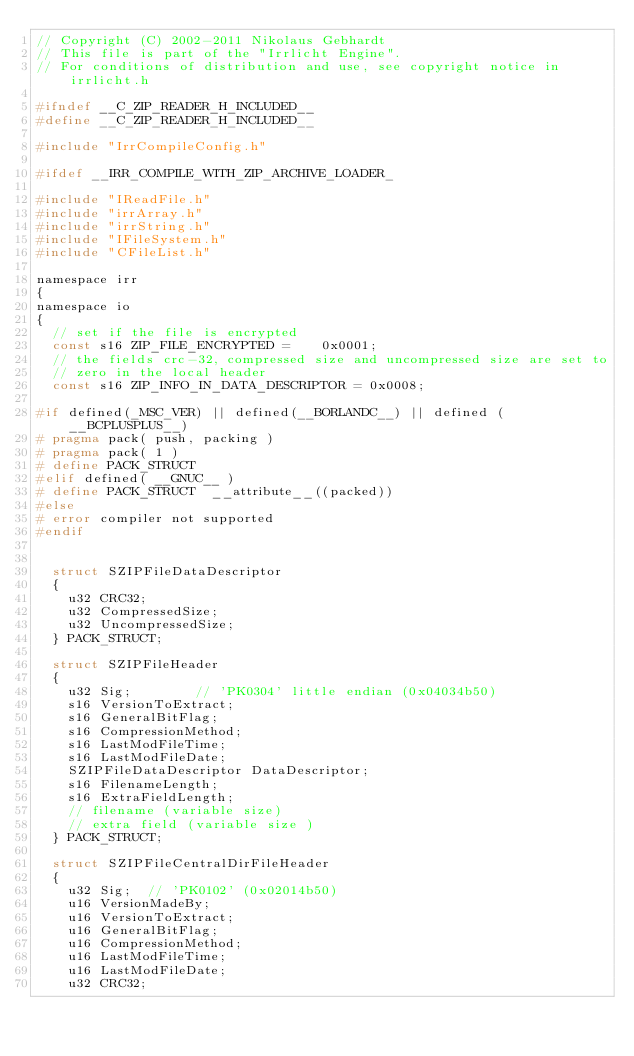<code> <loc_0><loc_0><loc_500><loc_500><_C_>// Copyright (C) 2002-2011 Nikolaus Gebhardt
// This file is part of the "Irrlicht Engine".
// For conditions of distribution and use, see copyright notice in irrlicht.h

#ifndef __C_ZIP_READER_H_INCLUDED__
#define __C_ZIP_READER_H_INCLUDED__

#include "IrrCompileConfig.h"

#ifdef __IRR_COMPILE_WITH_ZIP_ARCHIVE_LOADER_

#include "IReadFile.h"
#include "irrArray.h"
#include "irrString.h"
#include "IFileSystem.h"
#include "CFileList.h"

namespace irr
{
namespace io
{
	// set if the file is encrypted
	const s16 ZIP_FILE_ENCRYPTED =		0x0001;
	// the fields crc-32, compressed size and uncompressed size are set to
	// zero in the local header
	const s16 ZIP_INFO_IN_DATA_DESCRIPTOR =	0x0008;

#if defined(_MSC_VER) || defined(__BORLANDC__) || defined (__BCPLUSPLUS__)
#	pragma pack( push, packing )
#	pragma pack( 1 )
#	define PACK_STRUCT
#elif defined( __GNUC__ )
#	define PACK_STRUCT	__attribute__((packed))
#else
#	error compiler not supported
#endif


	struct SZIPFileDataDescriptor
	{
		u32 CRC32;
		u32 CompressedSize;
		u32 UncompressedSize;
	} PACK_STRUCT;

	struct SZIPFileHeader
	{
		u32 Sig;				// 'PK0304' little endian (0x04034b50)
		s16 VersionToExtract;
		s16 GeneralBitFlag;
		s16 CompressionMethod;
		s16 LastModFileTime;
		s16 LastModFileDate;
		SZIPFileDataDescriptor DataDescriptor;
		s16 FilenameLength;
		s16 ExtraFieldLength;
		// filename (variable size)
		// extra field (variable size )
	} PACK_STRUCT;

	struct SZIPFileCentralDirFileHeader
	{
		u32 Sig;	// 'PK0102' (0x02014b50)
		u16 VersionMadeBy;
		u16 VersionToExtract;
		u16 GeneralBitFlag;
		u16 CompressionMethod;
		u16 LastModFileTime;
		u16 LastModFileDate;
		u32 CRC32;</code> 